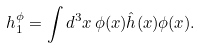Convert formula to latex. <formula><loc_0><loc_0><loc_500><loc_500>h _ { 1 } ^ { \phi } = \int d ^ { 3 } x \, \phi ( { x } ) \hat { h } ( { x } ) \phi ( { x } ) .</formula> 